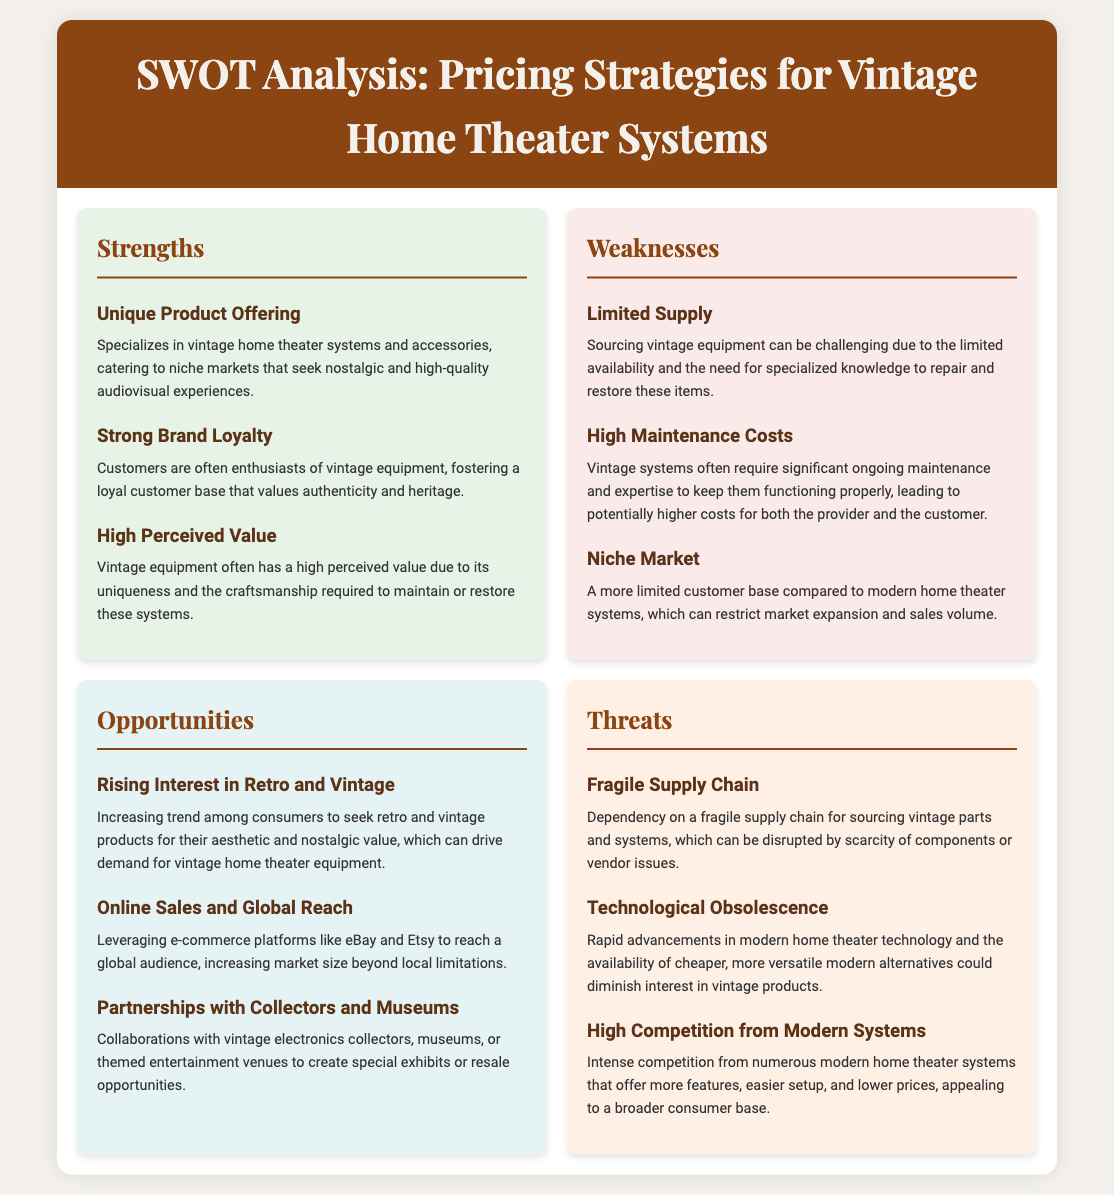what are the strengths of pricing strategies for vintage home theater systems? The strengths are detailed in a section of the document, highlighting unique product offerings and brand loyalty.
Answer: Unique Product Offering, Strong Brand Loyalty, High Perceived Value what is one of the weaknesses mentioned in the analysis? This is located in the weaknesses section of the document where issues like supply and maintenance costs are discussed.
Answer: Limited Supply how can vintage home theater equipment providers reach a global audience? The document specifies strategies in the opportunities section for enhancing market reach, particularly through online methods.
Answer: Online Sales and Global Reach what threat relates to technological advancements? The document outlines several threats, including how rapid changes in technology impact vintage products.
Answer: Technological Obsolescence how many strengths are listed in the analysis? The number of strengths can be counted within the strengths section of the document.
Answer: 3 